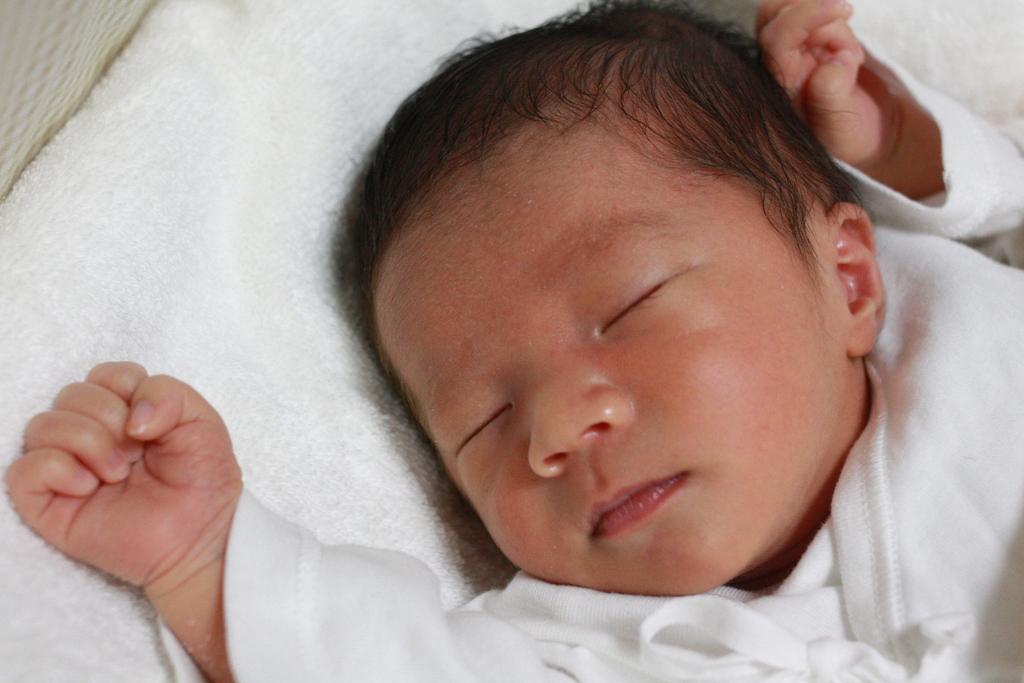How would you summarize this image in a sentence or two? I can see a baby is sleeping in this image in a white towel and the baby is wearing a white dress. 